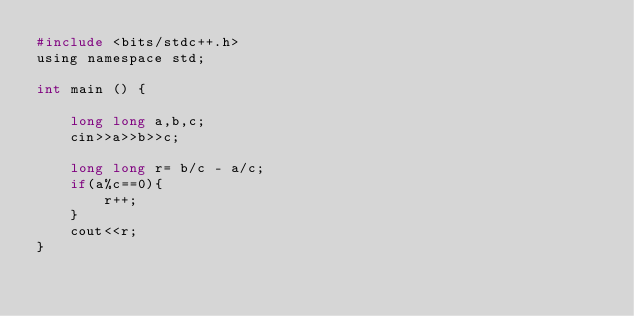<code> <loc_0><loc_0><loc_500><loc_500><_C_>#include <bits/stdc++.h>
using namespace std;

int main () {

    long long a,b,c;
    cin>>a>>b>>c;

    long long r= b/c - a/c;
    if(a%c==0){
        r++;
    }
    cout<<r;
}
</code> 